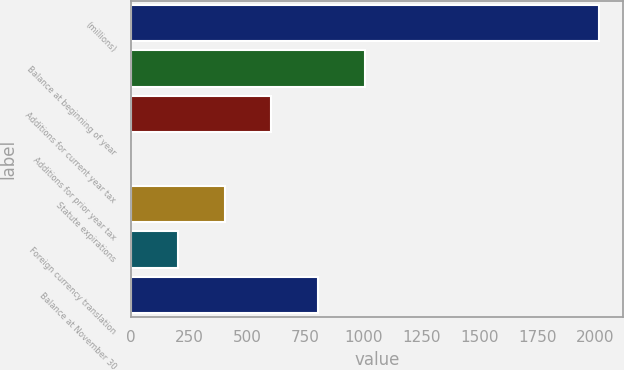Convert chart. <chart><loc_0><loc_0><loc_500><loc_500><bar_chart><fcel>(millions)<fcel>Balance at beginning of year<fcel>Additions for current year tax<fcel>Additions for prior year tax<fcel>Statute expirations<fcel>Foreign currency translation<fcel>Balance at November 30<nl><fcel>2017<fcel>1008.95<fcel>605.73<fcel>0.9<fcel>404.12<fcel>202.51<fcel>807.34<nl></chart> 